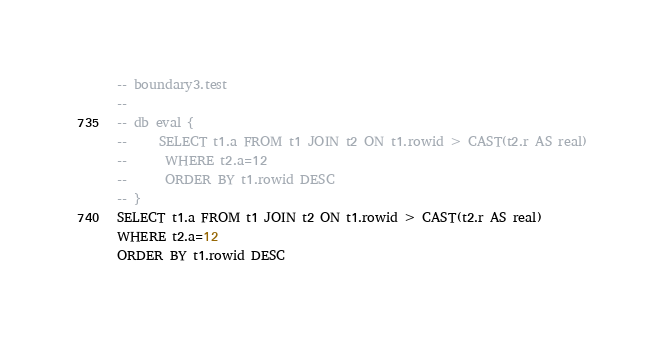<code> <loc_0><loc_0><loc_500><loc_500><_SQL_>-- boundary3.test
-- 
-- db eval {
--     SELECT t1.a FROM t1 JOIN t2 ON t1.rowid > CAST(t2.r AS real)
--      WHERE t2.a=12
--      ORDER BY t1.rowid DESC
-- }
SELECT t1.a FROM t1 JOIN t2 ON t1.rowid > CAST(t2.r AS real)
WHERE t2.a=12
ORDER BY t1.rowid DESC</code> 